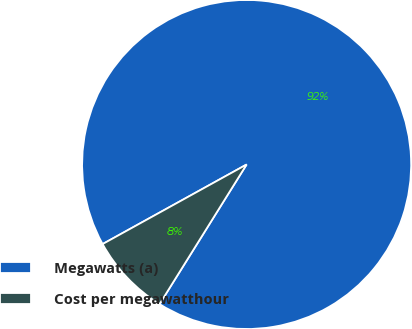Convert chart to OTSL. <chart><loc_0><loc_0><loc_500><loc_500><pie_chart><fcel>Megawatts (a)<fcel>Cost per megawatthour<nl><fcel>91.91%<fcel>8.09%<nl></chart> 